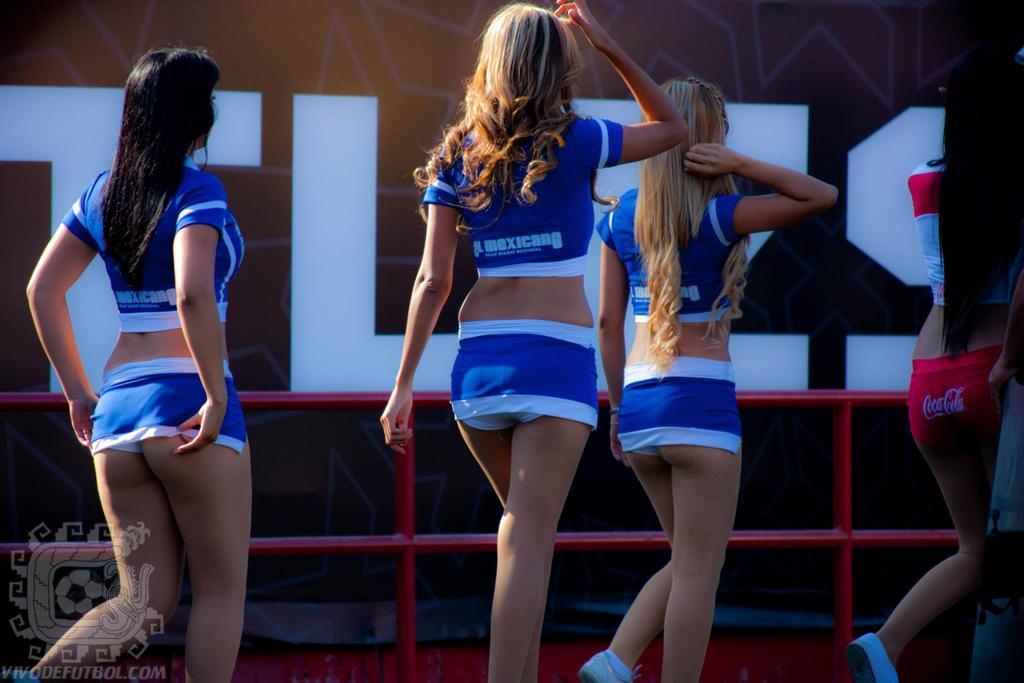In one or two sentences, can you explain what this image depicts? In this picture we can see four girls walking here, at the left bottom there is a logo, we can see railing here. 